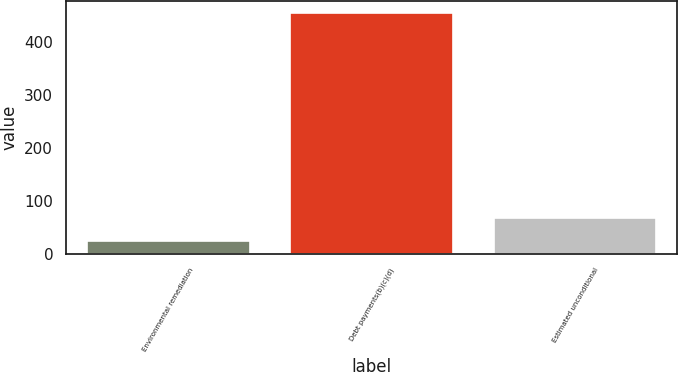<chart> <loc_0><loc_0><loc_500><loc_500><bar_chart><fcel>Environmental remediation<fcel>Debt payments(b)(c)(d)<fcel>Estimated unconditional<nl><fcel>24<fcel>455<fcel>67.1<nl></chart> 